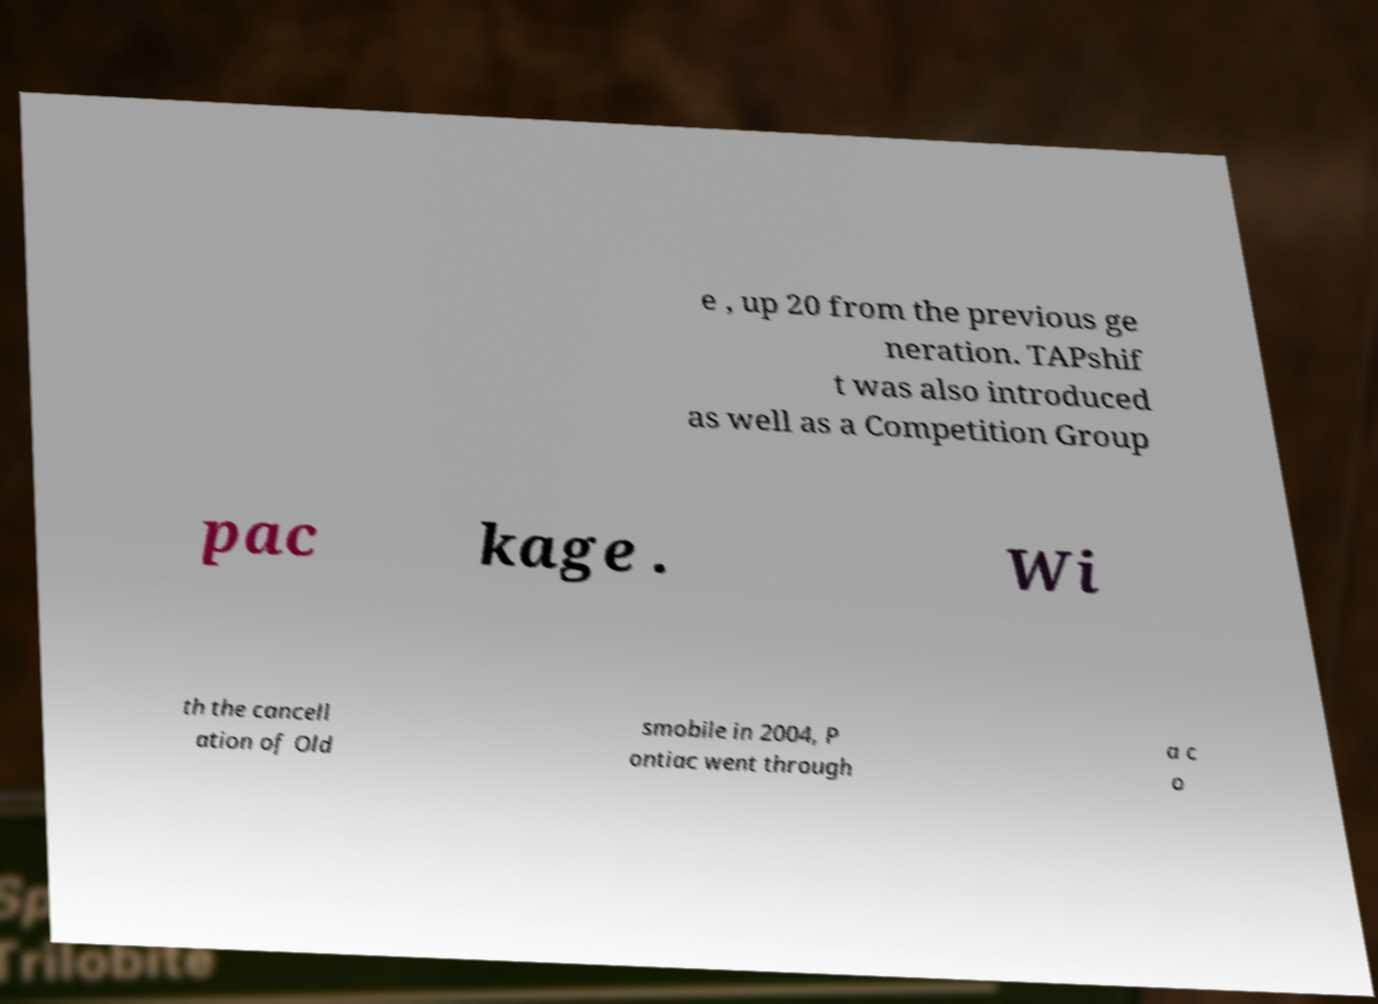What messages or text are displayed in this image? I need them in a readable, typed format. e , up 20 from the previous ge neration. TAPshif t was also introduced as well as a Competition Group pac kage . Wi th the cancell ation of Old smobile in 2004, P ontiac went through a c o 